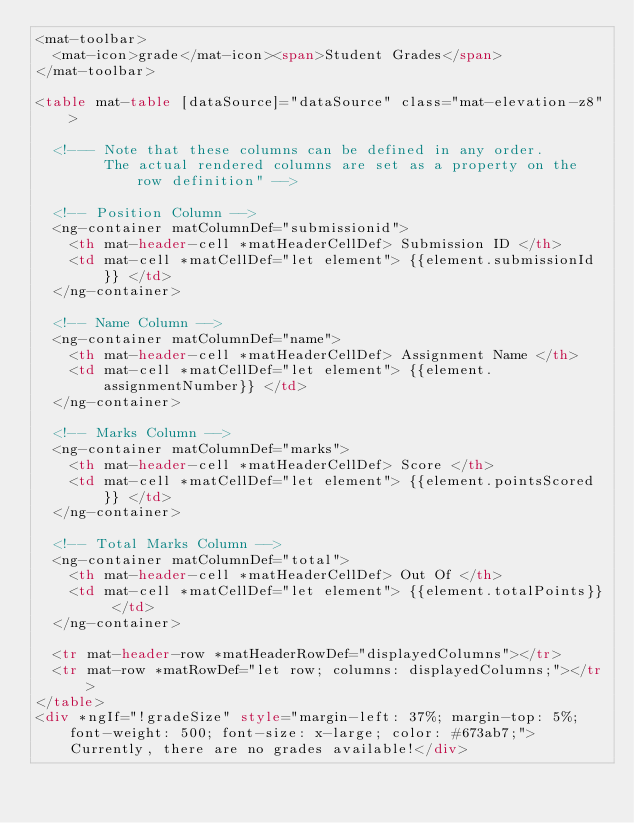<code> <loc_0><loc_0><loc_500><loc_500><_HTML_><mat-toolbar>
  <mat-icon>grade</mat-icon><span>Student Grades</span>
</mat-toolbar>

<table mat-table [dataSource]="dataSource" class="mat-elevation-z8">

  <!--- Note that these columns can be defined in any order.
        The actual rendered columns are set as a property on the row definition" -->

  <!-- Position Column -->
  <ng-container matColumnDef="submissionid">
    <th mat-header-cell *matHeaderCellDef> Submission ID </th>
    <td mat-cell *matCellDef="let element"> {{element.submissionId}} </td>
  </ng-container>

  <!-- Name Column -->
  <ng-container matColumnDef="name">
    <th mat-header-cell *matHeaderCellDef> Assignment Name </th>
    <td mat-cell *matCellDef="let element"> {{element.assignmentNumber}} </td>
  </ng-container>

  <!-- Marks Column -->
  <ng-container matColumnDef="marks">
    <th mat-header-cell *matHeaderCellDef> Score </th>
    <td mat-cell *matCellDef="let element"> {{element.pointsScored}} </td>
  </ng-container>

  <!-- Total Marks Column -->
  <ng-container matColumnDef="total">
    <th mat-header-cell *matHeaderCellDef> Out Of </th>
    <td mat-cell *matCellDef="let element"> {{element.totalPoints}} </td>
  </ng-container>

  <tr mat-header-row *matHeaderRowDef="displayedColumns"></tr>
  <tr mat-row *matRowDef="let row; columns: displayedColumns;"></tr>
</table>
<div *ngIf="!gradeSize" style="margin-left: 37%; margin-top: 5%; font-weight: 500; font-size: x-large; color: #673ab7;">Currently, there are no grades available!</div></code> 